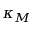Convert formula to latex. <formula><loc_0><loc_0><loc_500><loc_500>\kappa _ { M }</formula> 